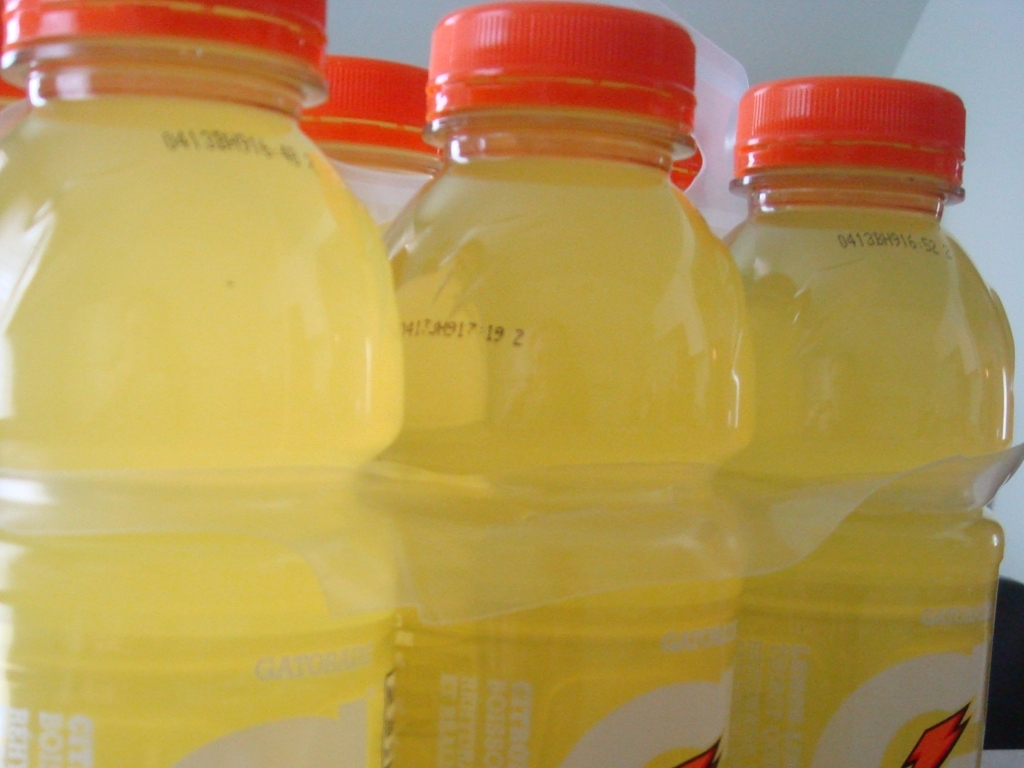Is the image clarity in this picture relatively high?
A. Yes
B. No
Answer with the option's letter from the given choices directly.
 A. 